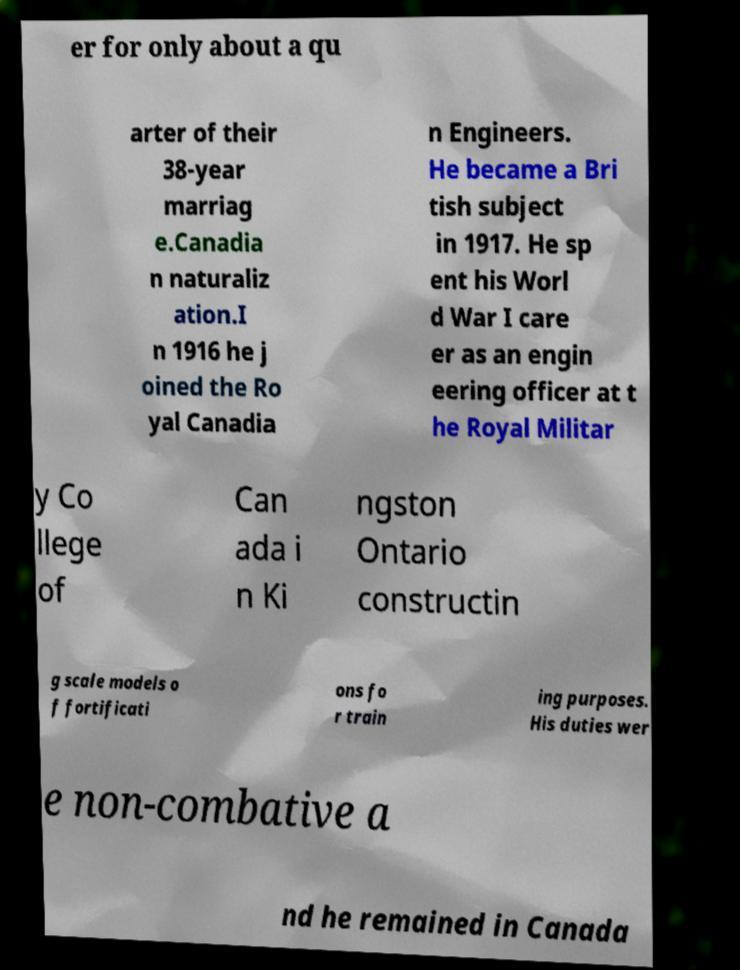Can you accurately transcribe the text from the provided image for me? er for only about a qu arter of their 38-year marriag e.Canadia n naturaliz ation.I n 1916 he j oined the Ro yal Canadia n Engineers. He became a Bri tish subject in 1917. He sp ent his Worl d War I care er as an engin eering officer at t he Royal Militar y Co llege of Can ada i n Ki ngston Ontario constructin g scale models o f fortificati ons fo r train ing purposes. His duties wer e non-combative a nd he remained in Canada 